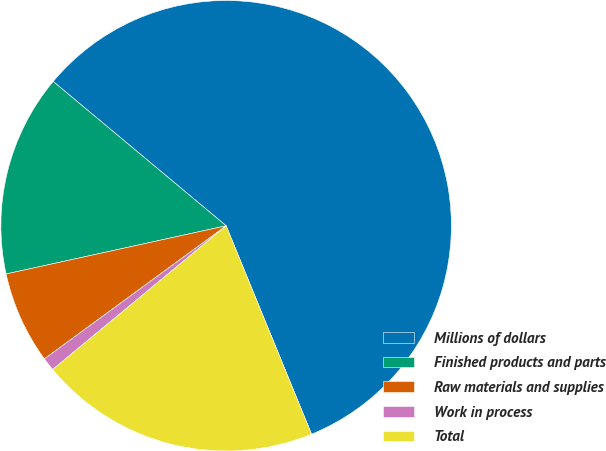<chart> <loc_0><loc_0><loc_500><loc_500><pie_chart><fcel>Millions of dollars<fcel>Finished products and parts<fcel>Raw materials and supplies<fcel>Work in process<fcel>Total<nl><fcel>57.74%<fcel>14.5%<fcel>6.63%<fcel>0.95%<fcel>20.18%<nl></chart> 